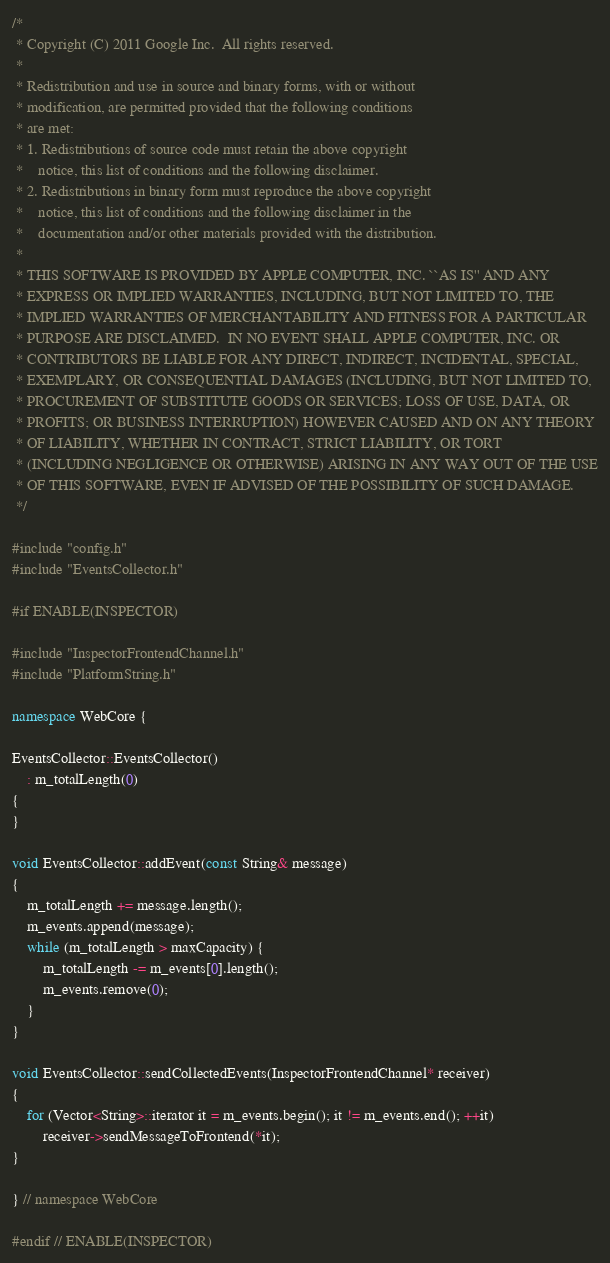Convert code to text. <code><loc_0><loc_0><loc_500><loc_500><_C++_>/*
 * Copyright (C) 2011 Google Inc.  All rights reserved.
 *
 * Redistribution and use in source and binary forms, with or without
 * modification, are permitted provided that the following conditions
 * are met:
 * 1. Redistributions of source code must retain the above copyright
 *    notice, this list of conditions and the following disclaimer.
 * 2. Redistributions in binary form must reproduce the above copyright
 *    notice, this list of conditions and the following disclaimer in the
 *    documentation and/or other materials provided with the distribution.
 *
 * THIS SOFTWARE IS PROVIDED BY APPLE COMPUTER, INC. ``AS IS'' AND ANY
 * EXPRESS OR IMPLIED WARRANTIES, INCLUDING, BUT NOT LIMITED TO, THE
 * IMPLIED WARRANTIES OF MERCHANTABILITY AND FITNESS FOR A PARTICULAR
 * PURPOSE ARE DISCLAIMED.  IN NO EVENT SHALL APPLE COMPUTER, INC. OR
 * CONTRIBUTORS BE LIABLE FOR ANY DIRECT, INDIRECT, INCIDENTAL, SPECIAL,
 * EXEMPLARY, OR CONSEQUENTIAL DAMAGES (INCLUDING, BUT NOT LIMITED TO,
 * PROCUREMENT OF SUBSTITUTE GOODS OR SERVICES; LOSS OF USE, DATA, OR
 * PROFITS; OR BUSINESS INTERRUPTION) HOWEVER CAUSED AND ON ANY THEORY
 * OF LIABILITY, WHETHER IN CONTRACT, STRICT LIABILITY, OR TORT
 * (INCLUDING NEGLIGENCE OR OTHERWISE) ARISING IN ANY WAY OUT OF THE USE
 * OF THIS SOFTWARE, EVEN IF ADVISED OF THE POSSIBILITY OF SUCH DAMAGE. 
 */

#include "config.h"
#include "EventsCollector.h"

#if ENABLE(INSPECTOR)

#include "InspectorFrontendChannel.h"
#include "PlatformString.h"

namespace WebCore {

EventsCollector::EventsCollector()
    : m_totalLength(0)
{
}

void EventsCollector::addEvent(const String& message)
{
    m_totalLength += message.length();
    m_events.append(message);
    while (m_totalLength > maxCapacity) {
        m_totalLength -= m_events[0].length();
        m_events.remove(0);
    }
}

void EventsCollector::sendCollectedEvents(InspectorFrontendChannel* receiver)
{
    for (Vector<String>::iterator it = m_events.begin(); it != m_events.end(); ++it)
        receiver->sendMessageToFrontend(*it);
}

} // namespace WebCore

#endif // ENABLE(INSPECTOR)
</code> 